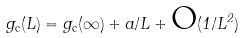Convert formula to latex. <formula><loc_0><loc_0><loc_500><loc_500>g _ { \text {c} } ( L ) = g _ { \text {c} } ( \infty ) + a / L + \text {O} ( 1 / L ^ { 2 } )</formula> 